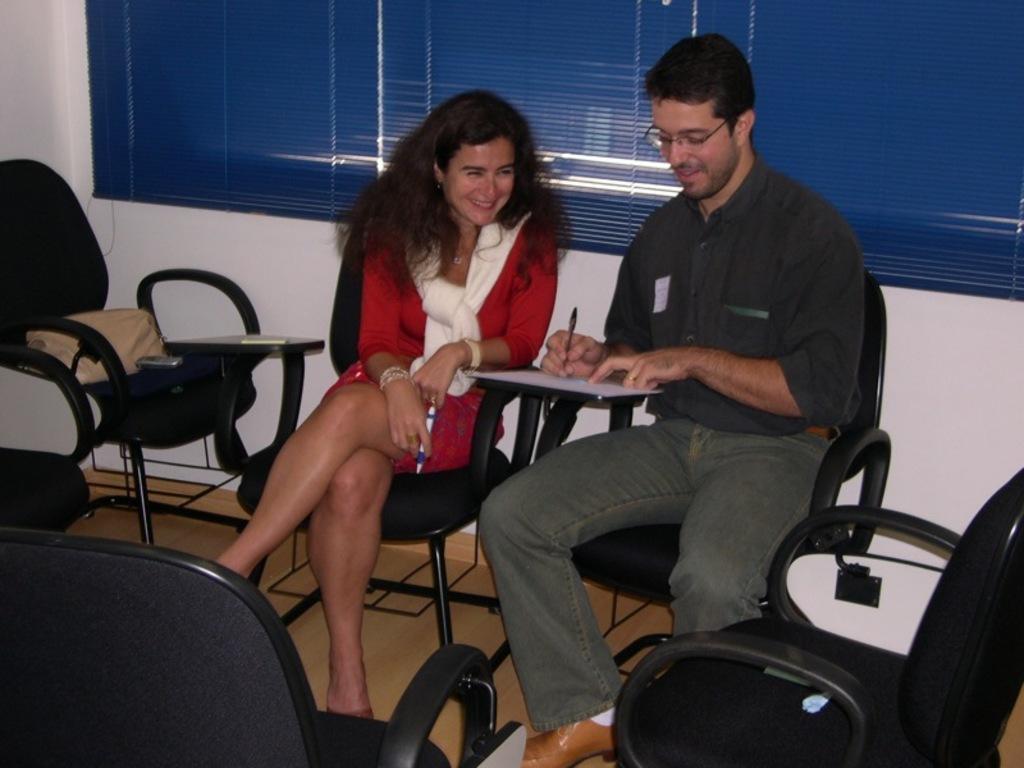In one or two sentences, can you explain what this image depicts? This picture is clicked inside a room. There are two people sitting on chairs and smiling. There are many chairs in the room. The woman is wearing a beautiful red dress and a white scarf and is holding pen in her hand. The man beside to her is holding a pen and writing on a paper. There is handbag placed on the chair. Behind them there is wall and window blinds.  